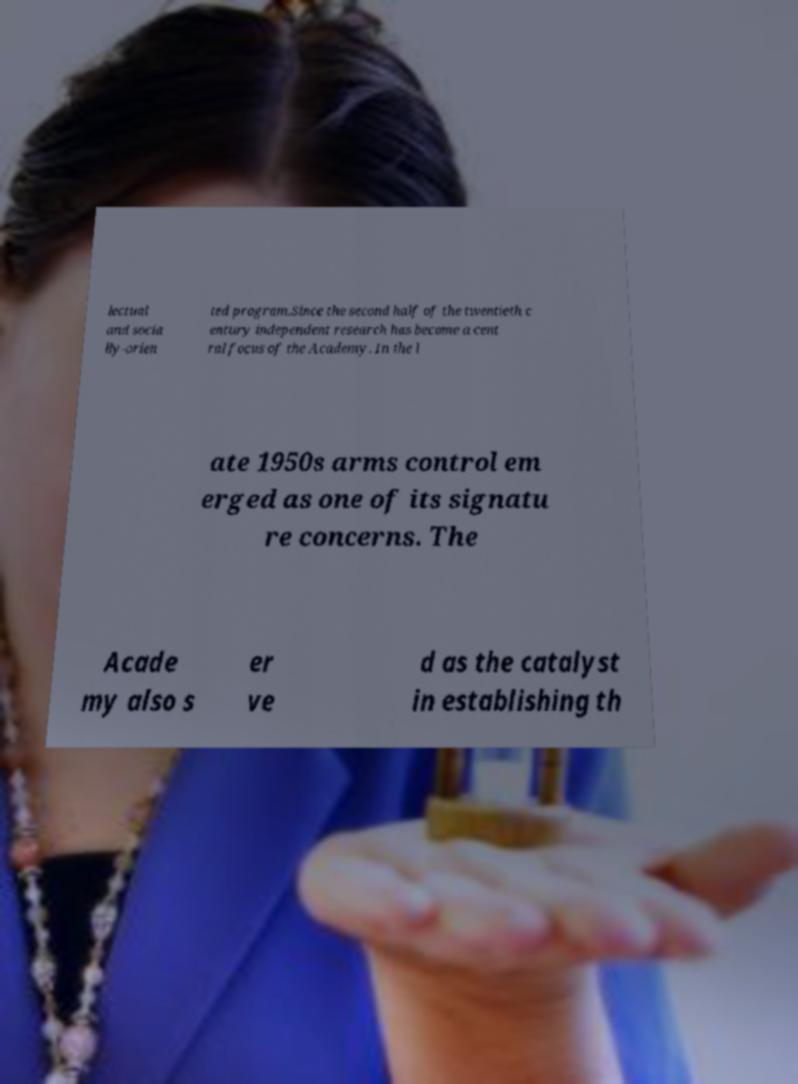Can you read and provide the text displayed in the image?This photo seems to have some interesting text. Can you extract and type it out for me? lectual and socia lly-orien ted program.Since the second half of the twentieth c entury independent research has become a cent ral focus of the Academy. In the l ate 1950s arms control em erged as one of its signatu re concerns. The Acade my also s er ve d as the catalyst in establishing th 